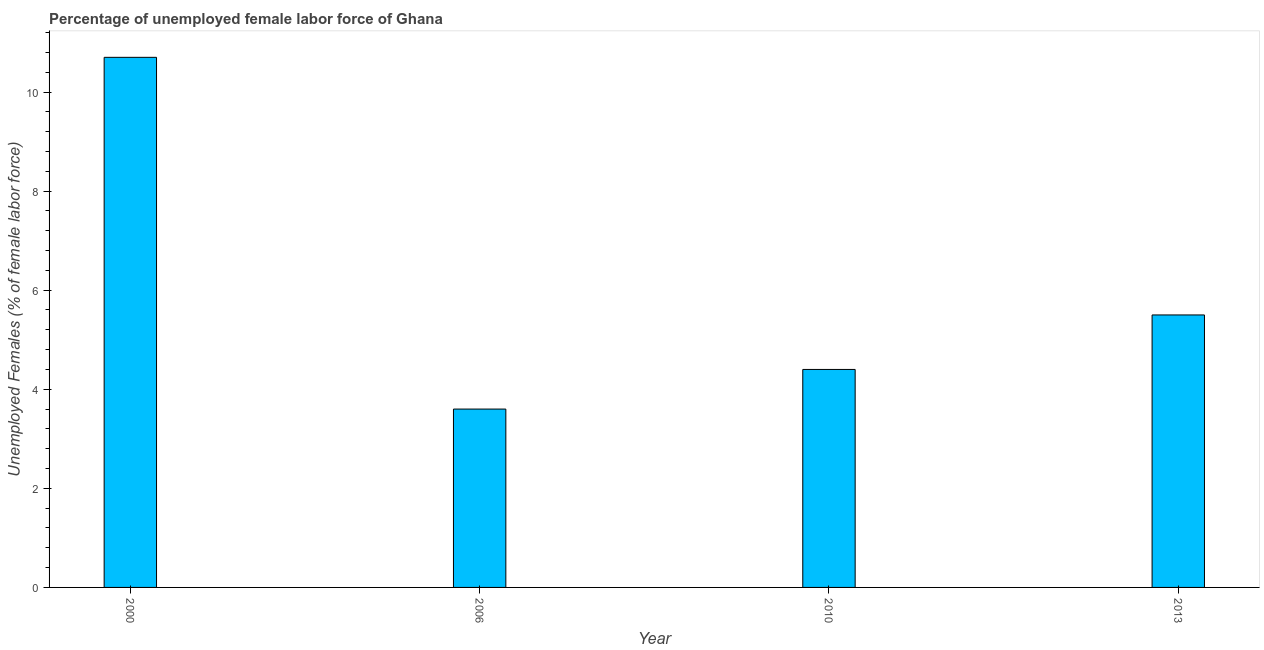Does the graph contain any zero values?
Offer a terse response. No. Does the graph contain grids?
Give a very brief answer. No. What is the title of the graph?
Your answer should be very brief. Percentage of unemployed female labor force of Ghana. What is the label or title of the X-axis?
Make the answer very short. Year. What is the label or title of the Y-axis?
Ensure brevity in your answer.  Unemployed Females (% of female labor force). What is the total unemployed female labour force in 2006?
Provide a succinct answer. 3.6. Across all years, what is the maximum total unemployed female labour force?
Offer a very short reply. 10.7. Across all years, what is the minimum total unemployed female labour force?
Provide a short and direct response. 3.6. In which year was the total unemployed female labour force maximum?
Your response must be concise. 2000. What is the sum of the total unemployed female labour force?
Make the answer very short. 24.2. What is the difference between the total unemployed female labour force in 2000 and 2006?
Ensure brevity in your answer.  7.1. What is the average total unemployed female labour force per year?
Offer a terse response. 6.05. What is the median total unemployed female labour force?
Give a very brief answer. 4.95. Do a majority of the years between 2000 and 2006 (inclusive) have total unemployed female labour force greater than 6.4 %?
Your response must be concise. No. What is the ratio of the total unemployed female labour force in 2000 to that in 2010?
Make the answer very short. 2.43. Is the total unemployed female labour force in 2010 less than that in 2013?
Your answer should be compact. Yes. Is the difference between the total unemployed female labour force in 2000 and 2013 greater than the difference between any two years?
Your response must be concise. No. What is the difference between the highest and the lowest total unemployed female labour force?
Your answer should be compact. 7.1. In how many years, is the total unemployed female labour force greater than the average total unemployed female labour force taken over all years?
Your answer should be compact. 1. How many bars are there?
Your answer should be very brief. 4. Are all the bars in the graph horizontal?
Offer a very short reply. No. Are the values on the major ticks of Y-axis written in scientific E-notation?
Offer a terse response. No. What is the Unemployed Females (% of female labor force) in 2000?
Your response must be concise. 10.7. What is the Unemployed Females (% of female labor force) of 2006?
Provide a short and direct response. 3.6. What is the Unemployed Females (% of female labor force) of 2010?
Offer a terse response. 4.4. What is the difference between the Unemployed Females (% of female labor force) in 2000 and 2013?
Keep it short and to the point. 5.2. What is the difference between the Unemployed Females (% of female labor force) in 2006 and 2013?
Offer a very short reply. -1.9. What is the difference between the Unemployed Females (% of female labor force) in 2010 and 2013?
Offer a terse response. -1.1. What is the ratio of the Unemployed Females (% of female labor force) in 2000 to that in 2006?
Make the answer very short. 2.97. What is the ratio of the Unemployed Females (% of female labor force) in 2000 to that in 2010?
Your answer should be compact. 2.43. What is the ratio of the Unemployed Females (% of female labor force) in 2000 to that in 2013?
Provide a succinct answer. 1.95. What is the ratio of the Unemployed Females (% of female labor force) in 2006 to that in 2010?
Provide a succinct answer. 0.82. What is the ratio of the Unemployed Females (% of female labor force) in 2006 to that in 2013?
Your answer should be very brief. 0.66. What is the ratio of the Unemployed Females (% of female labor force) in 2010 to that in 2013?
Your answer should be compact. 0.8. 